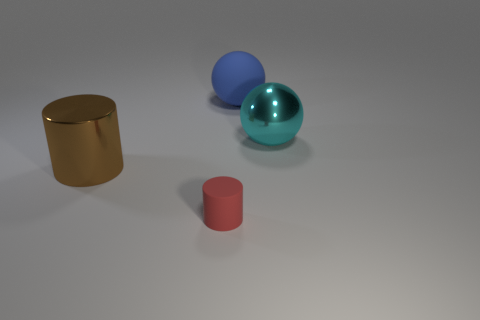Can you tell me the colors of the different objects in the picture? Certainly! In the image, there are three objects with distinct colors: a golden (or brownish) cylinder, a blue sphere, and a smaller red cylinder. 